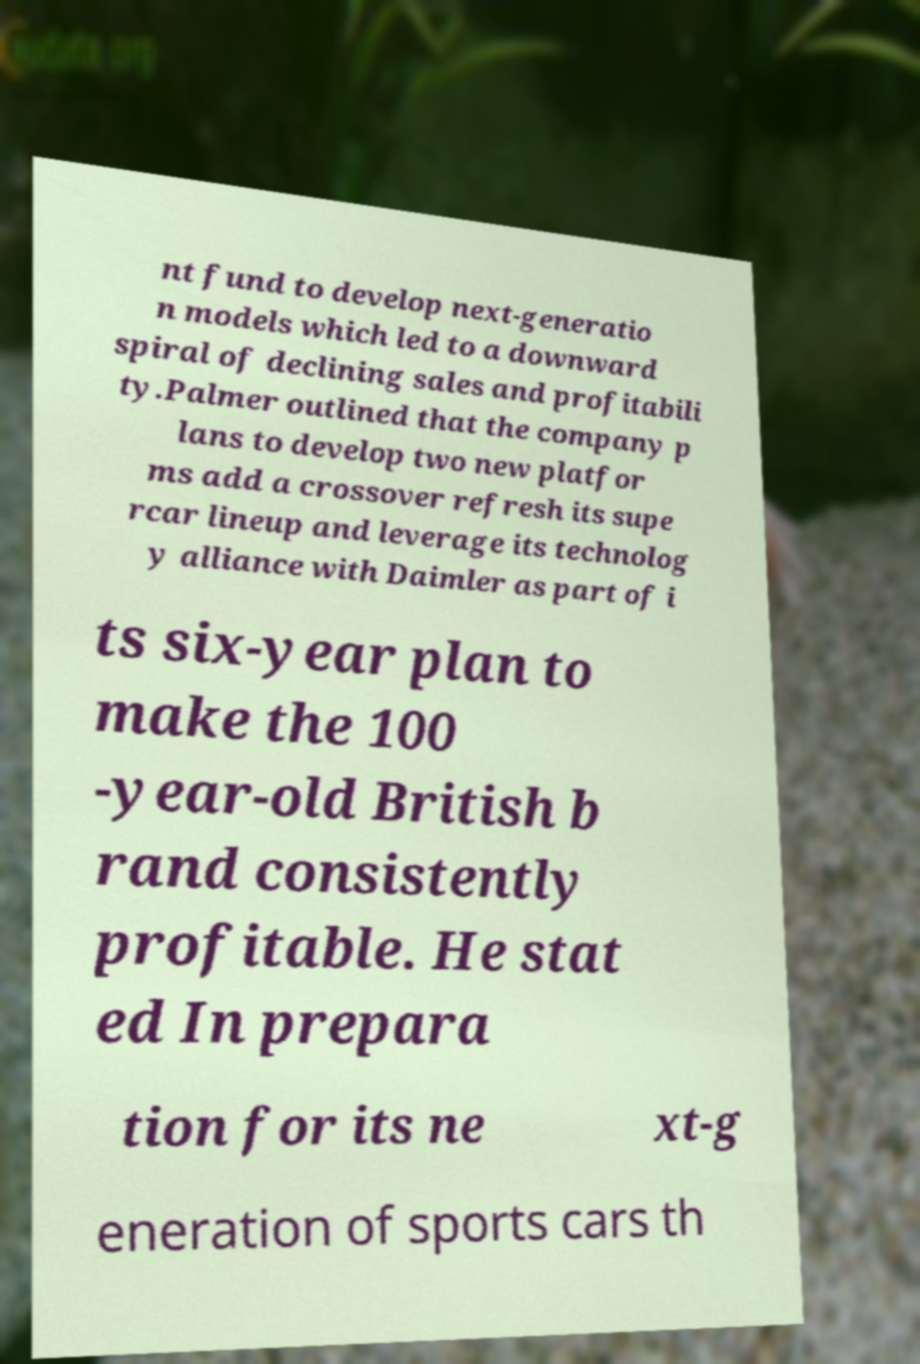What messages or text are displayed in this image? I need them in a readable, typed format. nt fund to develop next-generatio n models which led to a downward spiral of declining sales and profitabili ty.Palmer outlined that the company p lans to develop two new platfor ms add a crossover refresh its supe rcar lineup and leverage its technolog y alliance with Daimler as part of i ts six-year plan to make the 100 -year-old British b rand consistently profitable. He stat ed In prepara tion for its ne xt-g eneration of sports cars th 